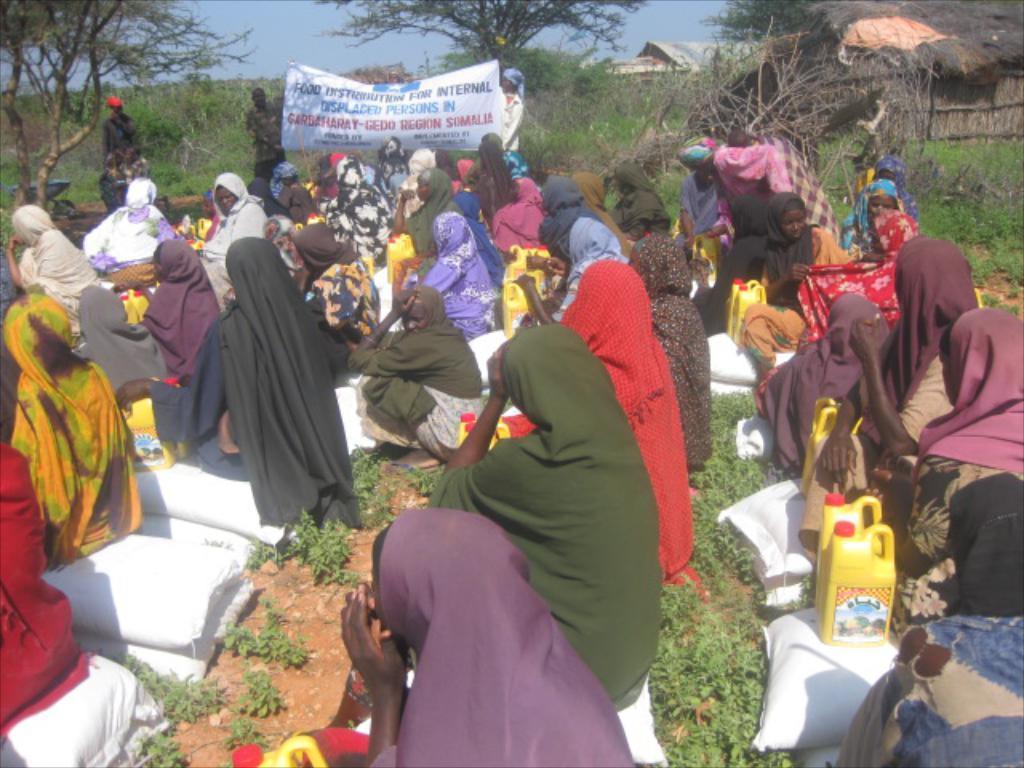Could you give a brief overview of what you see in this image? This picture is clicked outside and we can see the group of people sitting on the ground and we can see the bottles and many other objects are placed on the ground and we can see the plants, dry stems, huts, some houses and in the background we can see the group of people standing and we can see the text on the banner and we can see the sky, trees, plants and many other objects. 